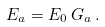<formula> <loc_0><loc_0><loc_500><loc_500>E _ { a } = E _ { 0 } \, G _ { a } \, .</formula> 